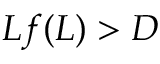<formula> <loc_0><loc_0><loc_500><loc_500>L f ( L ) > D</formula> 